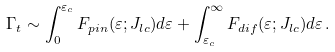Convert formula to latex. <formula><loc_0><loc_0><loc_500><loc_500>\Gamma _ { t } \sim \int _ { 0 } ^ { \varepsilon _ { c } } F _ { p i n } ( \varepsilon ; J _ { l c } ) d \varepsilon + \int _ { \varepsilon _ { c } } ^ { \infty } F _ { d i f } ( \varepsilon ; J _ { l c } ) d \varepsilon \, .</formula> 